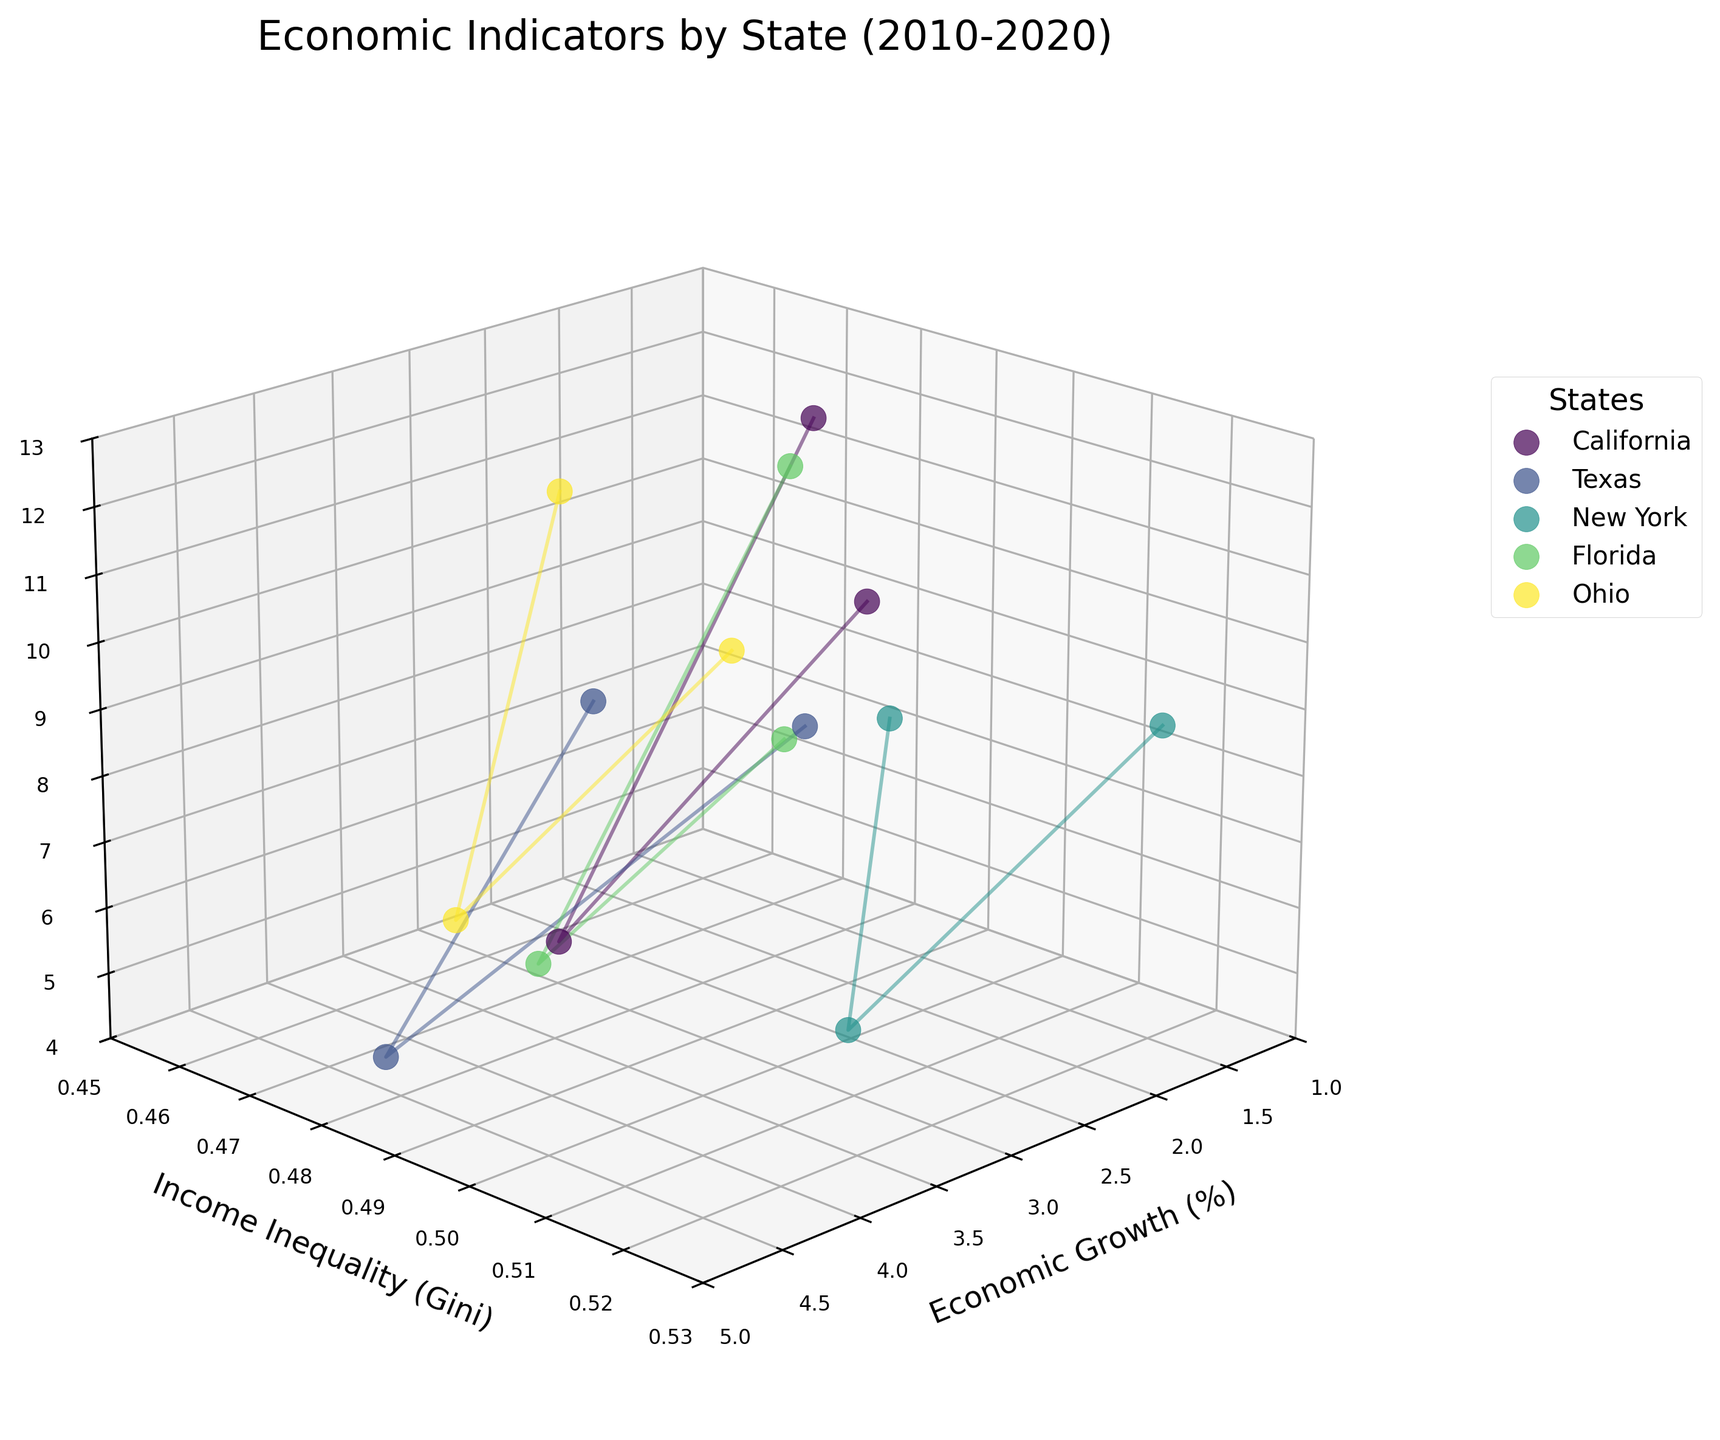What is the title of the figure? The title of the figure is located at the top and provides an overall description of the data being visualized. Based on the provided plot code, it is "Economic Indicators by State (2010-2020)".
Answer: Economic Indicators by State (2010-2020) Which state has data points with the highest income inequality? To find this, examine the y-axis, which represents Income Inequality (Gini). Look for the highest points along this axis and identify the corresponding state. New York has the highest income inequality values.
Answer: New York Which state had the highest unemployment rate in 2010? Observe the z-axis, which represents the Unemployment Rate (%). Look specifically at the data points corresponding to the year 2010. California had the highest unemployment rate in 2010.
Answer: California Which state shows the most considerable improvement in unemployment rate from 2010 to 2015? Calculate the difference in unemployment rates between 2010 and 2015 for each state and identify the largest decrease. California went from 12.2% in 2010 to 6.2% in 2015, a decrease of 6 percentage points.
Answer: California What is the general trend of income inequality from 2010 to 2020 for each state? Look at the data points on the y-axis (Income Inequality). For each state, notice the position of points over the years. In general, income inequality increases over time for all states.
Answer: It increases Between Texas and Ohio, which state had a higher economic growth rate in 2015? Compare the economic growth rates by observing the data points along the x-axis for both states in 2015. Texas had an economic growth rate of 4.5%, while Ohio had 3.3% in 2015.
Answer: Texas For the state of New York, how did economic growth and unemployment rate change from 2015 to 2020? Identify New York's data points for 2015 and 2020. In 2015, the economic growth was 3.2% and unemployment rate was 5.3%. In 2020, economic growth decreased to 1.5% and unemployment rate increased to 8.8%.
Answer: Economic growth decreased, unemployment rate increased Which state had the smallest change in economic growth between 2010 and 2020? Measure the change in economic growth for each state by subtracting the 2010 figure from the 2020 figure. California had the smallest change, from 1.8% to 2.1%, which is a 0.3 percentage point increase.
Answer: California Which states had a consistent increase in economic growth from 2010 to 2015? Focus on the economic growth from 2010 to 2015 for each state, noting any increase. All states, California, Texas, New York, Florida, and Ohio, show an increase in economic growth over this period.
Answer: California, Texas, New York, Florida, Ohio How do the unemployment rates of Florida and Texas compare in 2020? Compare the 2020 data points for Florida and Texas along the z-axis for unemployment rates. Florida’s rate is 7.9%, and Texas’s rate is 7.6%.
Answer: Florida has a slightly higher unemployment rate than Texas 